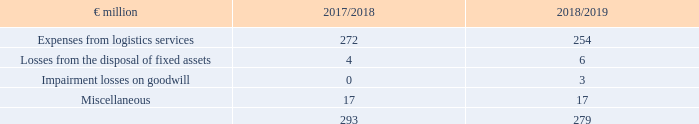5. Other operating expenses
The expenses from logistics services provided by METRO LOGISTICS to companies intended for sale and non-group companies are offset by income from logistics services, which are reported under other operating income.
What is offset by income from logistics services? The expenses from logistics services provided by metro logistics to companies intended for sale and non-group companies. Where is income from logistics services reported? Reported under other operating income. What are the components under Other operating expenses in the table? Expenses from logistics services, losses from the disposal of fixed assets, impairment losses on goodwill, miscellaneous. In which year was the amount of Losses from the disposal of fixed assets larger? 6>4
Answer: 2018/2019. What was the change in Losses from the disposal of fixed assets in 2018/2019 from 2017/2018?
Answer scale should be: million. 6-4
Answer: 2. What was the percentage change in Losses from the disposal of fixed assets in 2018/2019 from 2017/2018?
Answer scale should be: percent. (6-4)/4
Answer: 50. 